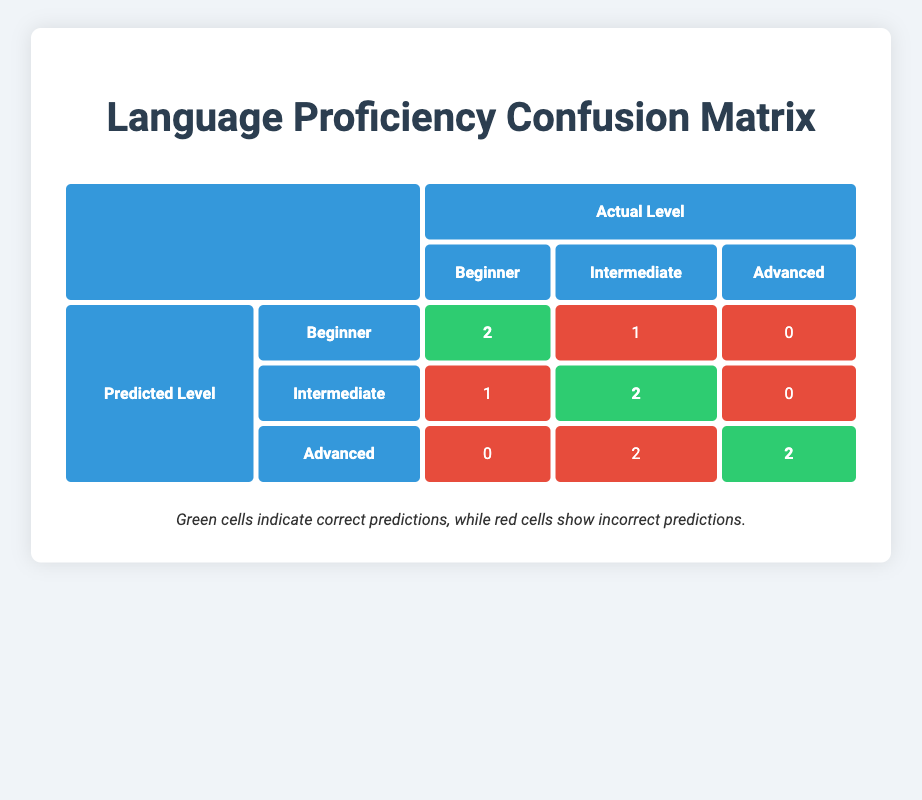What is the total number of students assessed as "Beginner"? In the table, we can find the counts for the predicted level "Beginner" which are in the "Beginner" row. There are 2 students predicted as "Beginner" whose actual level is "Beginner", and 1 predicted as "Intermediate" whose actual level is "Beginner". Thus, the total number of students assessed as "Beginner" is 2 + 1 = 3.
Answer: 3 How many students were correctly identified as "Intermediate"? The table indicates the number of students whose predicted level is "Intermediate" and their actual level is also "Intermediate." There are 2 students in this category, therefore, 2 students were accurately identified.
Answer: 2 What's the total number of incorrect predictions for "Advanced"? From the "Advanced" predicted level row, there are 0 students whose actual level is "Beginner" (incorrect), 2 whose actual level is "Intermediate" (incorrect), and 2 whose actual level is "Advanced" (correct). Thus, the total number of incorrect predictions for "Advanced" is 0 + 2 = 2.
Answer: 2 Is it true that no students were predicted as "Beginner" when their actual proficiency was "Advanced"? Looking at the row for predicted "Beginner," we see it lists 2 students correctly identified as "Beginner," 1 incorrectly identified as "Intermediate," and 0 as "Advanced." Since there are no students listed in this row for an actual level of "Advanced," the statement is true.
Answer: Yes What is the total number of students predicted as "Advanced"? In the table, we examine the "Advanced" predicted level, which shows all counts: 0 students as "Beginner," 2 as "Intermediate," and 2 as "Advanced." Adding these yields 0 + 2 + 2 = 4 total students predicted as "Advanced."
Answer: 4 How many students were accurately predicted across all language proficiency levels? We need to assess the correctly predicted students from all proficiency levels. The counts are: 2 for "Beginner," 2 for "Intermediate," and 2 for "Advanced." Summing these values gives us 2 + 2 + 2 = 6, hence the total number of correctly predicted students is 6.
Answer: 6 What percentage of students predicted as "Intermediate" were actually at the "Intermediate" level? For students predicted as "Intermediate," we find that there were 3 total (1 incorrect prediction and 2 correct). Among them, 2 were actually "Intermediate." To find the percentage: (2 correct predictions / 3 predicted as "Intermediate") * 100 = approximately 66.67%.
Answer: 66.67% How many students had their language level underestimated? Underestimation occurs when a student’s actual level is higher than what was predicted. From the "Beginner" and "Intermediate" predicted rows, we find 1 student whose actual level was "Intermediate" but predicted as "Beginner," and 2 students whose actual level was "Advanced" but predicted as "Intermediate." Summing these gives 1 + 2 = 3 students whose levels were underestimated.
Answer: 3 